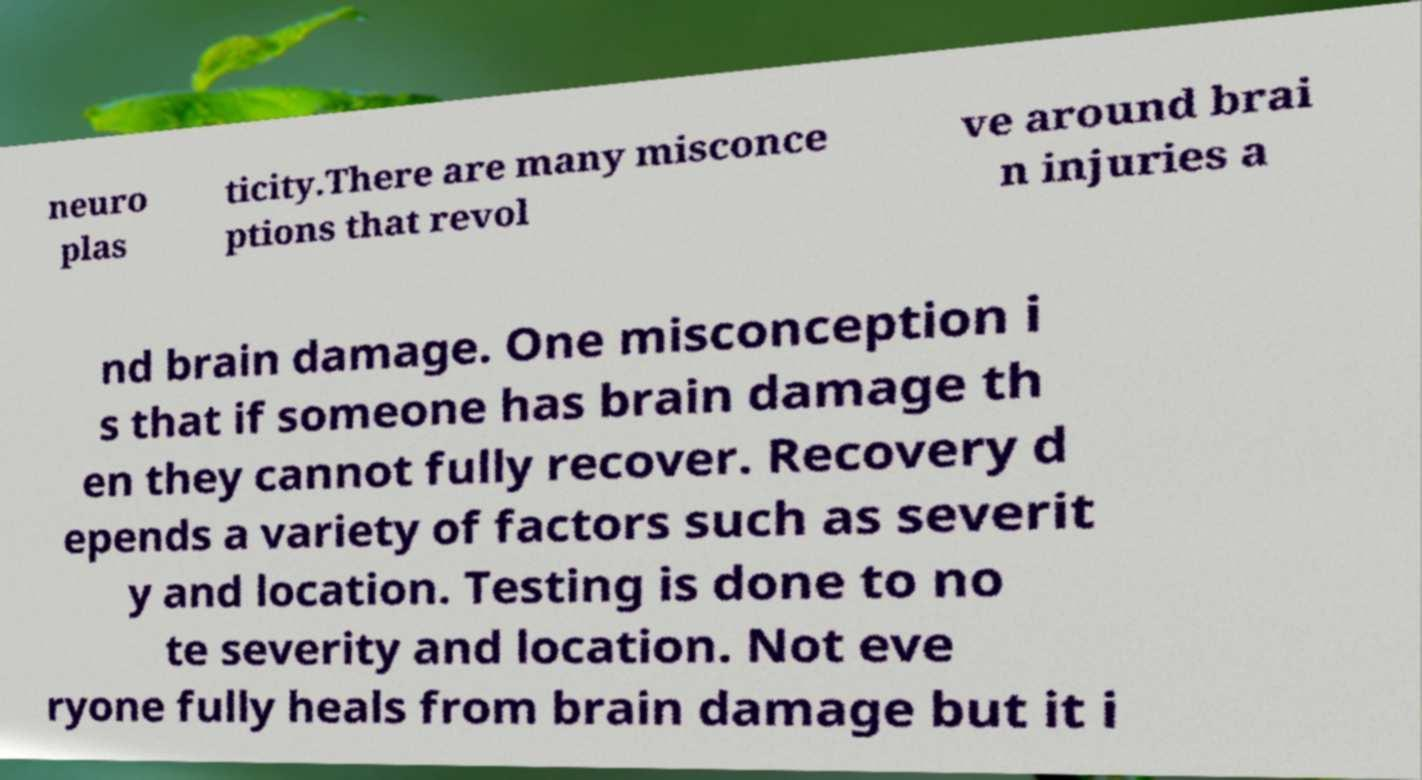There's text embedded in this image that I need extracted. Can you transcribe it verbatim? neuro plas ticity.There are many misconce ptions that revol ve around brai n injuries a nd brain damage. One misconception i s that if someone has brain damage th en they cannot fully recover. Recovery d epends a variety of factors such as severit y and location. Testing is done to no te severity and location. Not eve ryone fully heals from brain damage but it i 